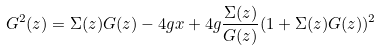Convert formula to latex. <formula><loc_0><loc_0><loc_500><loc_500>G ^ { 2 } ( z ) = \Sigma ( z ) G ( z ) - 4 g x + 4 g { \frac { \Sigma ( z ) } { G ( z ) } } ( 1 + \Sigma ( z ) G ( z ) ) ^ { 2 }</formula> 